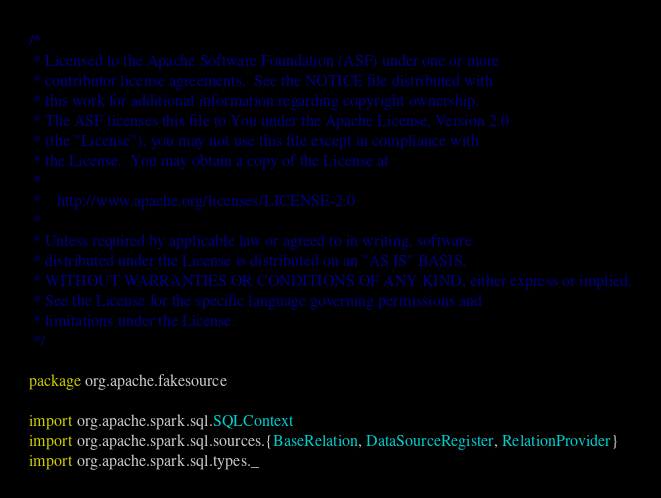Convert code to text. <code><loc_0><loc_0><loc_500><loc_500><_Scala_>/*
 * Licensed to the Apache Software Foundation (ASF) under one or more
 * contributor license agreements.  See the NOTICE file distributed with
 * this work for additional information regarding copyright ownership.
 * The ASF licenses this file to You under the Apache License, Version 2.0
 * (the "License"); you may not use this file except in compliance with
 * the License.  You may obtain a copy of the License at
 *
 *    http://www.apache.org/licenses/LICENSE-2.0
 *
 * Unless required by applicable law or agreed to in writing, software
 * distributed under the License is distributed on an "AS IS" BASIS,
 * WITHOUT WARRANTIES OR CONDITIONS OF ANY KIND, either express or implied.
 * See the License for the specific language governing permissions and
 * limitations under the License.
 */

package org.apache.fakesource

import org.apache.spark.sql.SQLContext
import org.apache.spark.sql.sources.{BaseRelation, DataSourceRegister, RelationProvider}
import org.apache.spark.sql.types._

</code> 